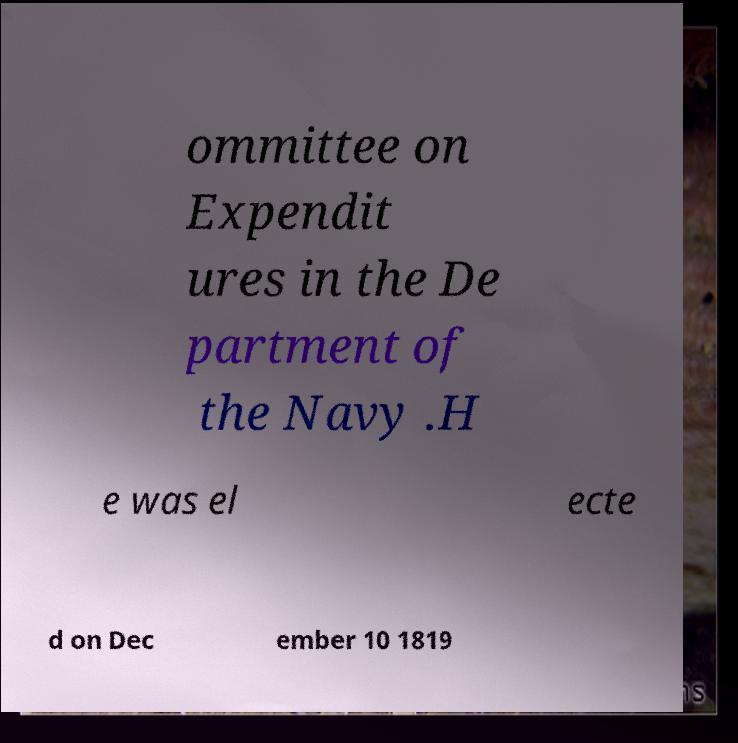Could you assist in decoding the text presented in this image and type it out clearly? ommittee on Expendit ures in the De partment of the Navy .H e was el ecte d on Dec ember 10 1819 